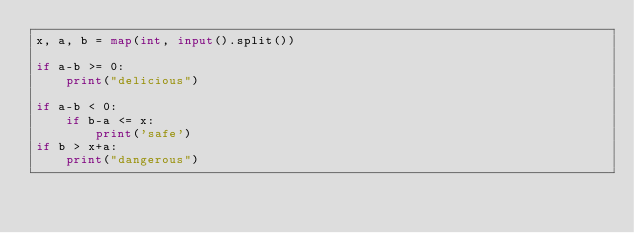Convert code to text. <code><loc_0><loc_0><loc_500><loc_500><_Python_>x, a, b = map(int, input().split())

if a-b >= 0:
    print("delicious")

if a-b < 0:
    if b-a <= x:
        print('safe')
if b > x+a:
    print("dangerous")
</code> 